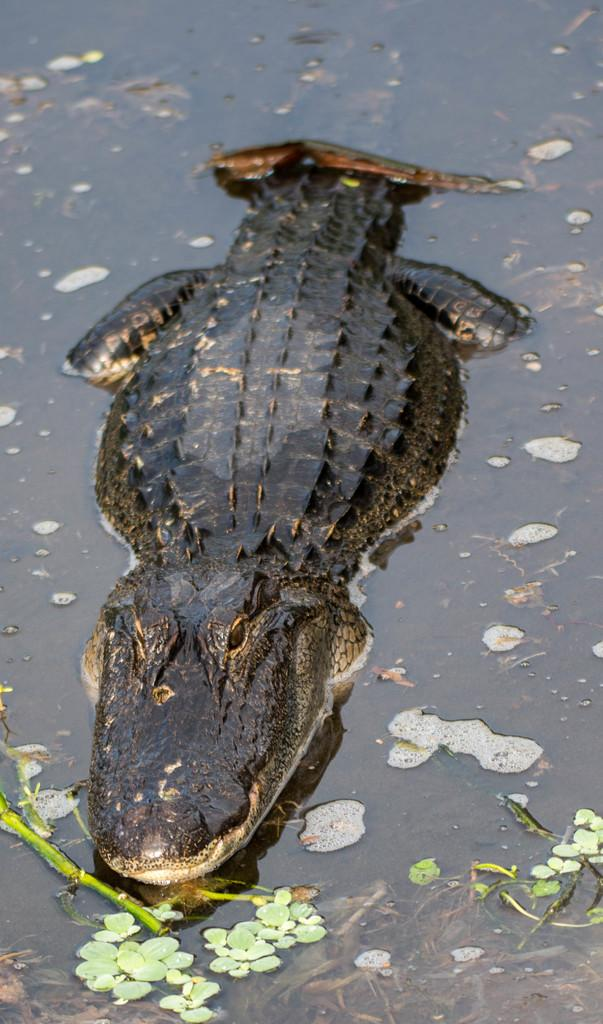What is at the bottom of the image? There is water at the bottom of the image. What can be found in the water? There is a crocodile and leaves in the water. What type of light is being used by the stranger in the image? There is no stranger present in the image, so it is not possible to determine what type of light they might be using. 